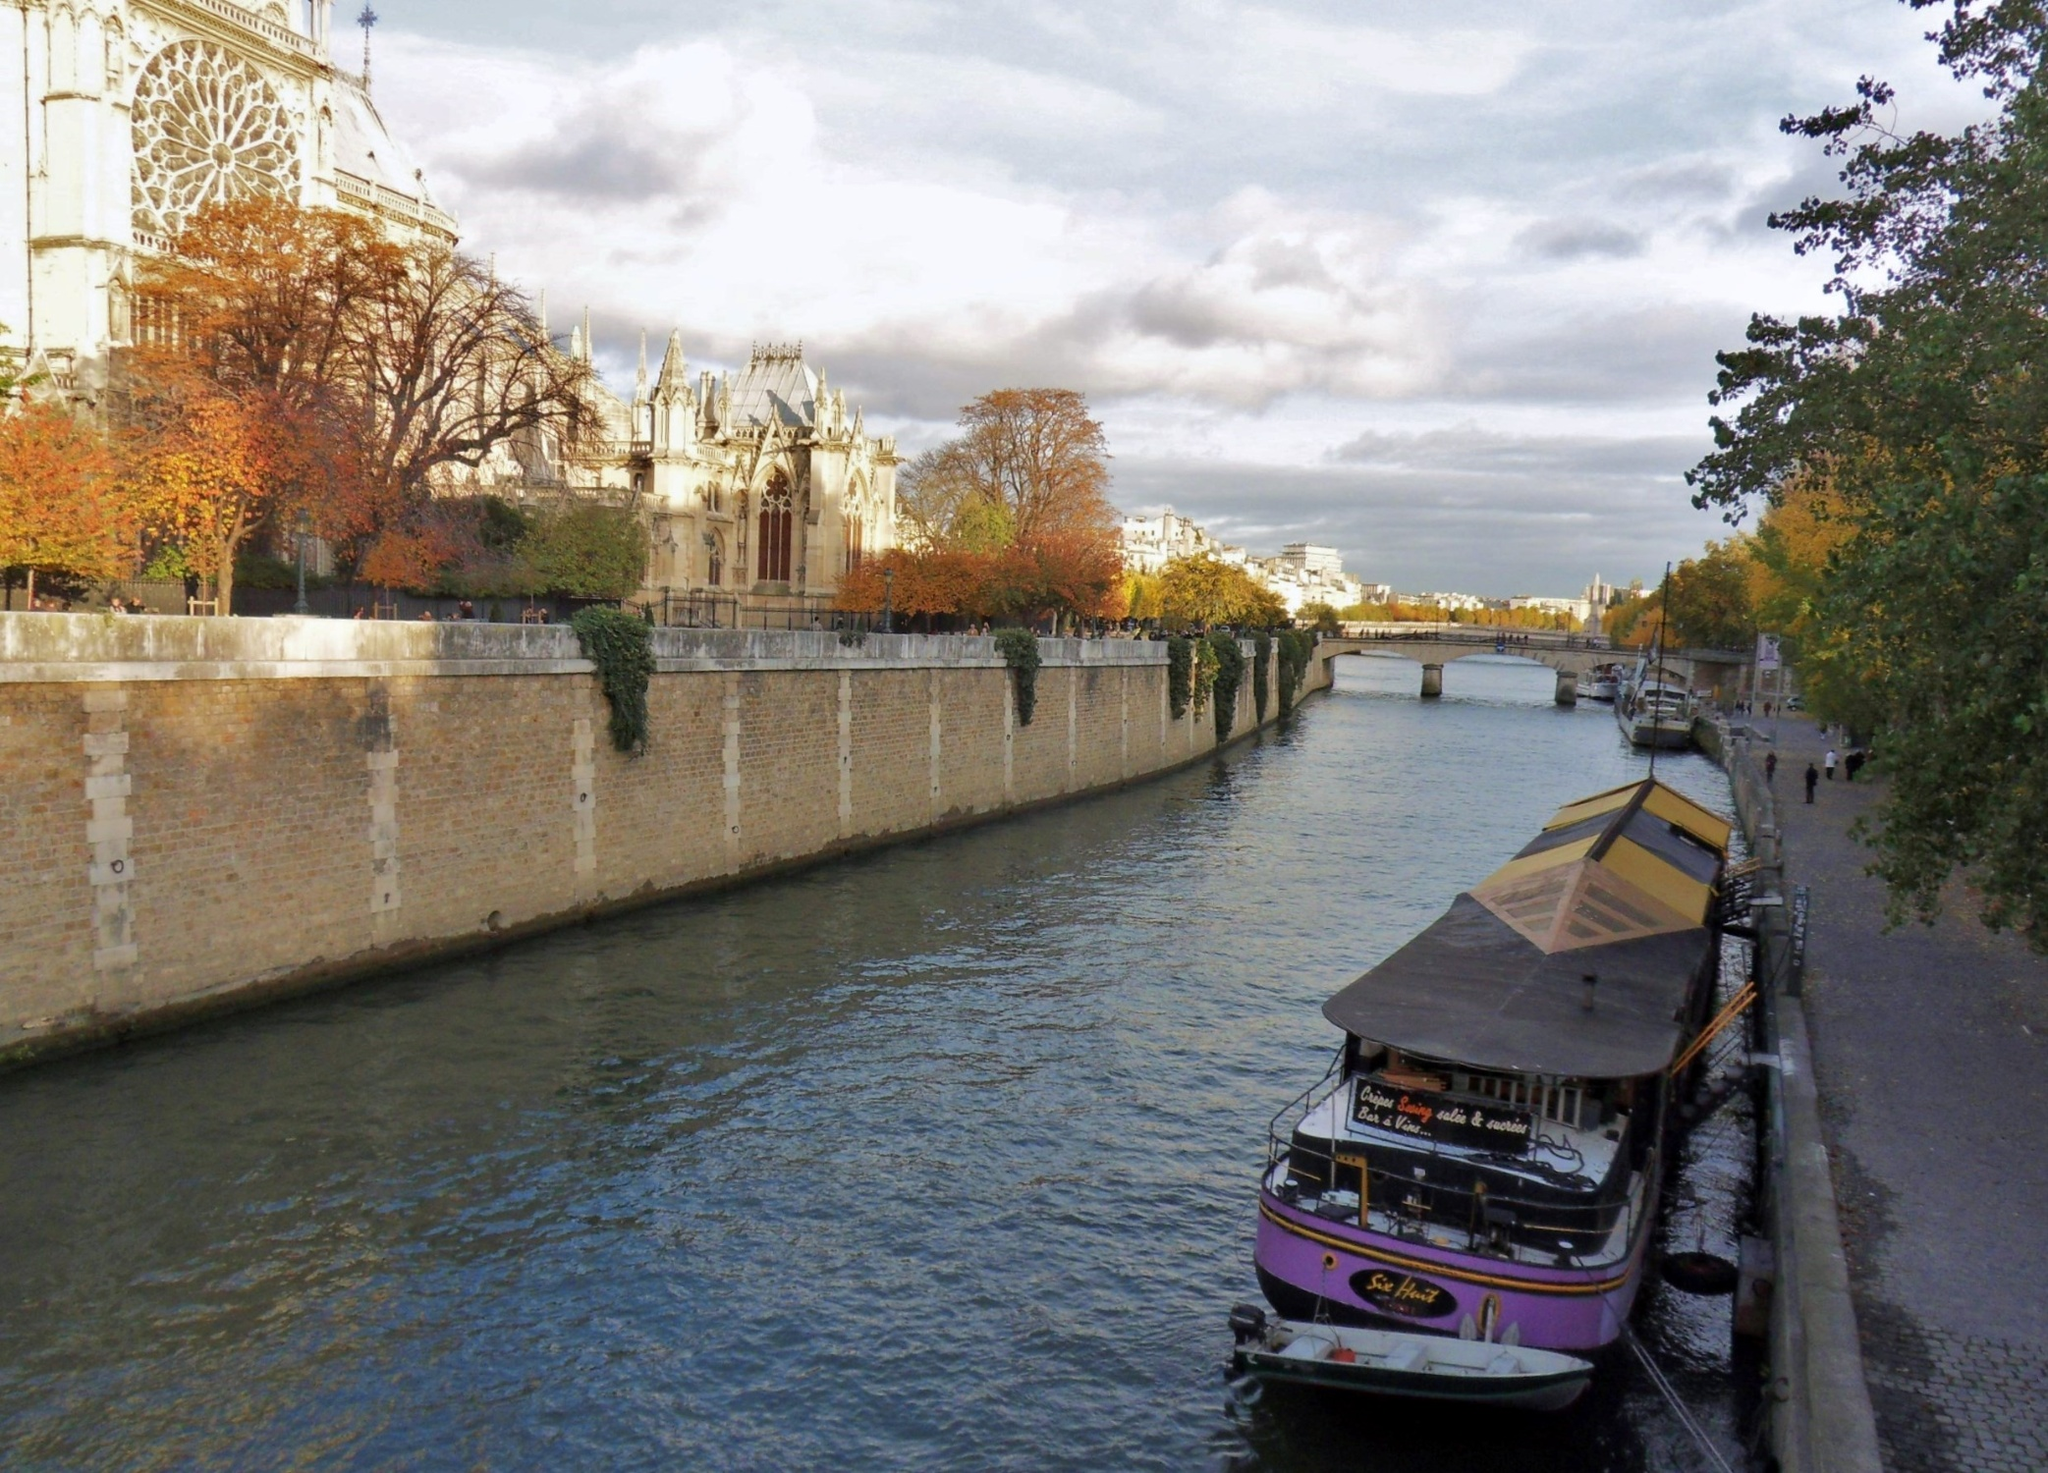What do you think is going on in this snapshot? This image beautifully captures an autumn day along the Seine River in Paris, illustrating a harmonious blend of nature, architecture, and urban life. On the right side of the image, a boat with a distinctive brown roof and pink and white striped awning is moored on the riverbank. The stone wall on the left is adorned by a line of trees showcasing their vibrant autumn colors, with leaves in brilliant shades of orange and red. These colors add a sense of warmth and seasonality to the scene. Dominating the background is the majestic Notre Dame Cathedral, recognizable by its iconic spire and flying buttresses, which rise proudly against a sky scattered with white clouds. The cathedral's presence not only provides historical context but also a sense of depth to the composition. In essence, this snapshot encapsulates the serene elegance and historical richness of a Parisian autumn day. 